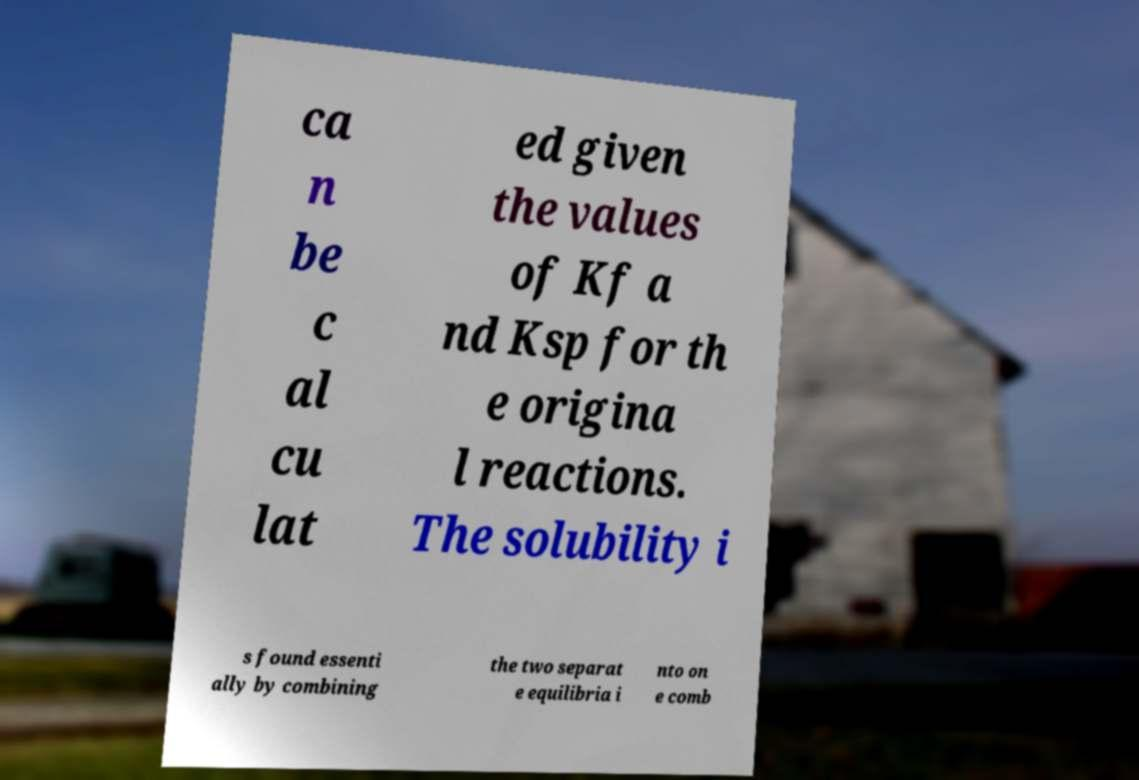I need the written content from this picture converted into text. Can you do that? ca n be c al cu lat ed given the values of Kf a nd Ksp for th e origina l reactions. The solubility i s found essenti ally by combining the two separat e equilibria i nto on e comb 